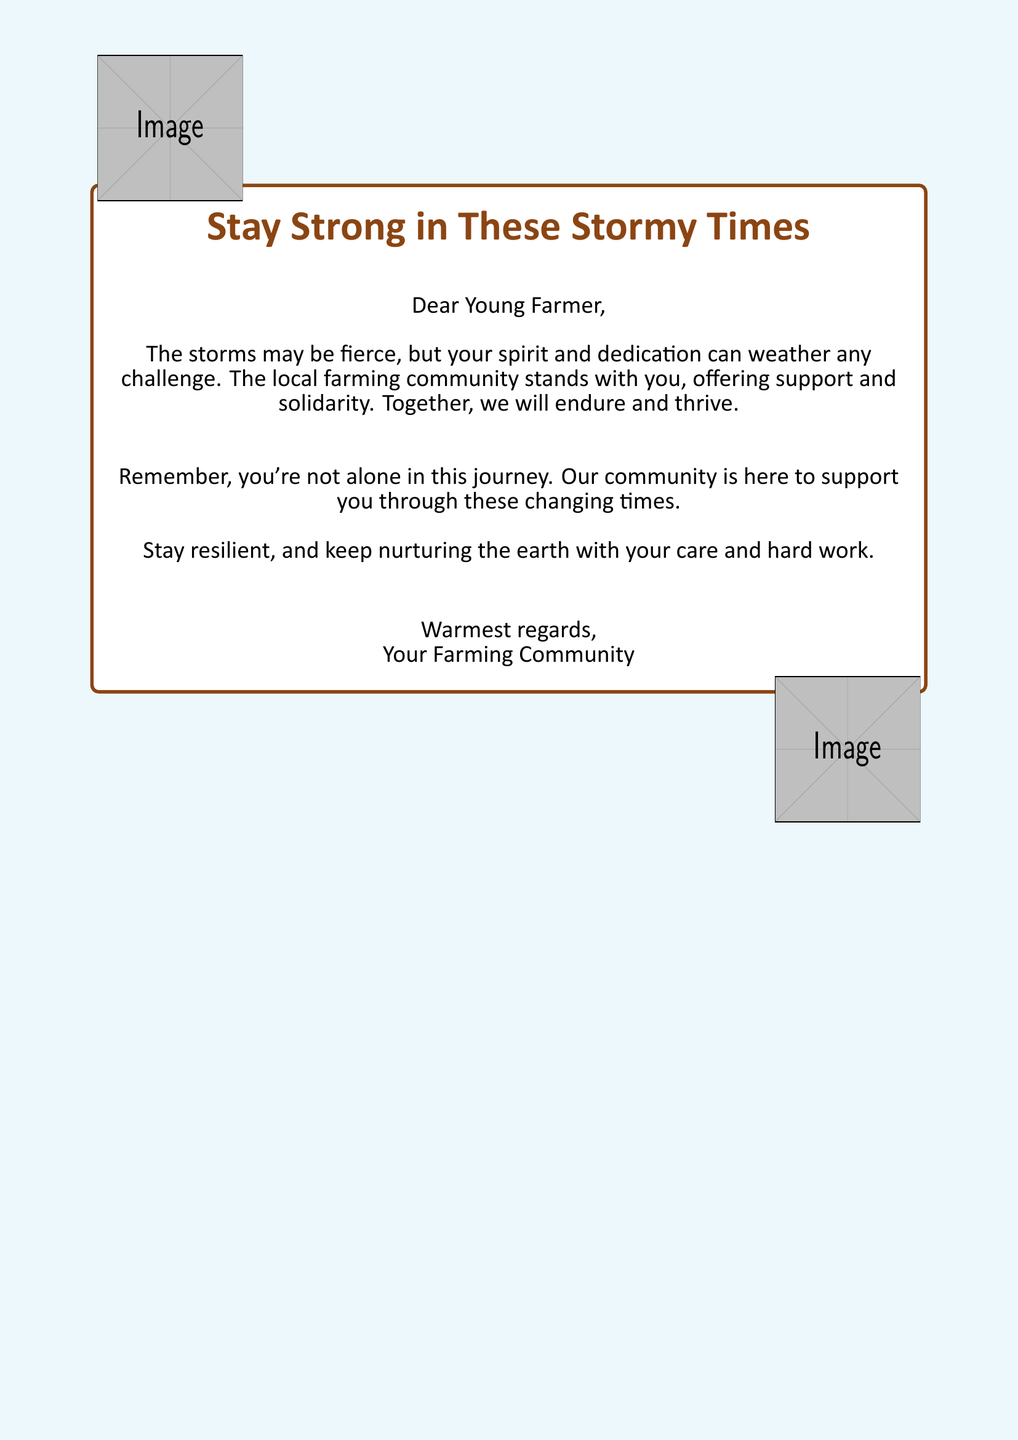What is the main message of the card? The main message of the card conveys encouragement and support for the young farmer during challenging weather conditions.
Answer: Stay Strong in These Stormy Times Who is the card addressed to? The card is specifically addressed to a young farmer, indicating its target audience.
Answer: Young Farmer What does the card suggest the community offers? The card highlights the community's willingness to provide support and solidarity to the young farmer facing challenges.
Answer: Support and solidarity What kind of imagery is used in the card? The card features imagery related to a farm environment, specifically showing a barn enduring a storm.
Answer: Barn enduring a storm What is a key emotional theme of the card? The card evokes feelings of encouragement and solidarity in the face of adversity, fostering a sense of community support.
Answer: Encouragement and solidarity How does the card suggest farmers cope with storms? The card emphasizes the idea that together, farmers can endure and thrive despite the challenging conditions.
Answer: Together endure and thrive 